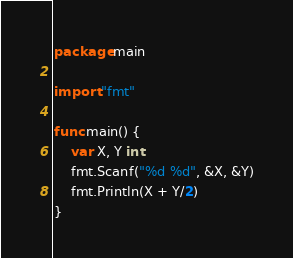<code> <loc_0><loc_0><loc_500><loc_500><_Go_>package main

import "fmt"

func main() {
	var X, Y int
	fmt.Scanf("%d %d", &X, &Y)
	fmt.Println(X + Y/2)
}
</code> 